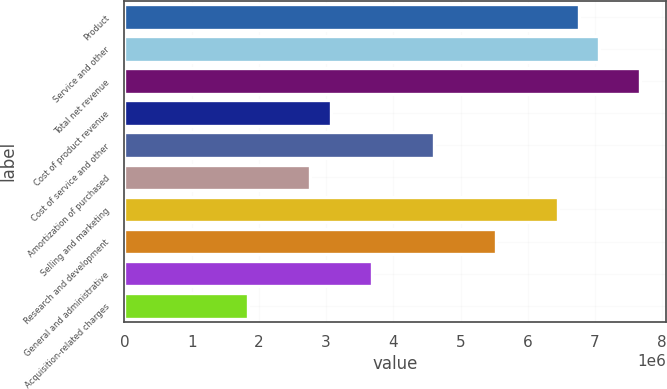Convert chart. <chart><loc_0><loc_0><loc_500><loc_500><bar_chart><fcel>Product<fcel>Service and other<fcel>Total net revenue<fcel>Cost of product revenue<fcel>Cost of service and other<fcel>Amortization of purchased<fcel>Selling and marketing<fcel>Research and development<fcel>General and administrative<fcel>Acquisition-related charges<nl><fcel>6.75614e+06<fcel>7.06324e+06<fcel>7.67743e+06<fcel>3.07097e+06<fcel>4.60646e+06<fcel>2.76388e+06<fcel>6.44904e+06<fcel>5.52775e+06<fcel>3.68517e+06<fcel>1.84258e+06<nl></chart> 